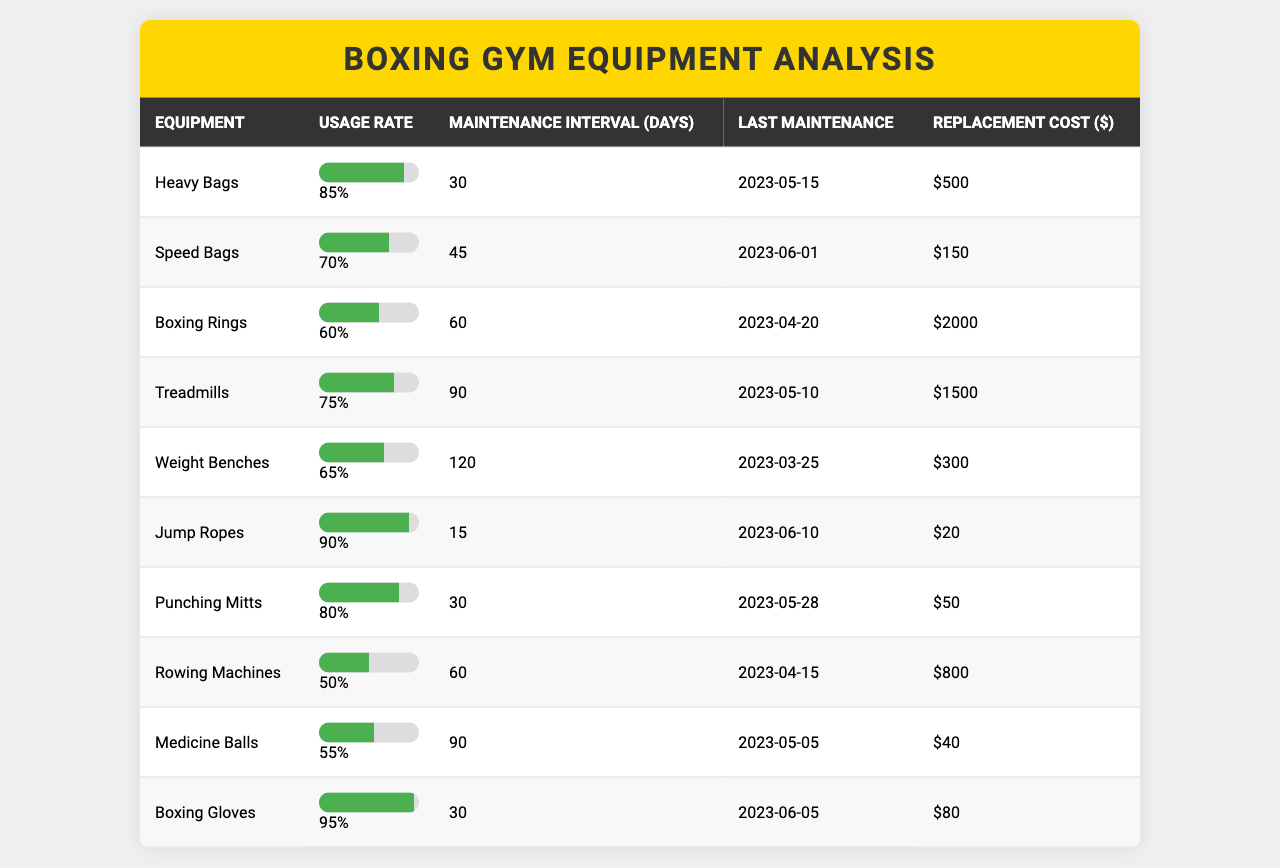What is the usage rate of Punching Mitts? The table shows that the usage rate for Punching Mitts is listed under the Usage Rate column corresponding to their row, which is 80%.
Answer: 80% Which equipment has the highest usage rate? By comparing the Usage Rate column values, Heavy Bags have the highest usage rate at 85%.
Answer: Heavy Bags What is the maintenance interval for Rowing Machines? The table provides a specific maintenance interval of 60 days for Rowing Machines, as indicated in the Maintenance Interval column.
Answer: 60 days When was the last maintenance for Weight Benches? The Last Maintenance column shows that Weight Benches had their last maintenance on 2023-03-25.
Answer: 2023-03-25 How many days do Jump Ropes need between maintenance? According to the Maintenance Interval column, Jump Ropes require maintenance every 15 days.
Answer: 15 days Is the replacement cost for Speed Bags less than $200? By checking the Replacement Cost column, we see that Speed Bags cost $150, which is indeed less than $200.
Answer: Yes What is the average usage rate of all equipment? To get the average, sum all the usage rates (85 + 70 + 60 + 75 + 65 + 90 + 80 + 50 + 55 + 95 = 825) and divide by the number of equipment (10), yielding an average of 82.5.
Answer: 82.5 How do the replacement costs correlate with the usage rates? Analyze the relationship by comparing the Replacement Cost and Usage Rate columns; for example, Punching Mitts have an 80% usage rate and a replacement cost of $50. Generally, higher usage rates tend to have lower replacement costs and vice versa, indicating a potential strategy to invest in more frequently used equipment.
Answer: Variable correlation observed Which equipment requires the most frequent maintenance and what is that interval? By inspecting the Maintenance Interval column, Jump Ropes require maintenance every 15 days, making them the most frequently maintained equipment.
Answer: Jump Ropes, 15 days From the last maintenance dates, which equipment had the latest service? Looking at the Last Maintenance column, the latest service was for Jump Ropes on 2023-06-10.
Answer: Jump Ropes, 2023-06-10 